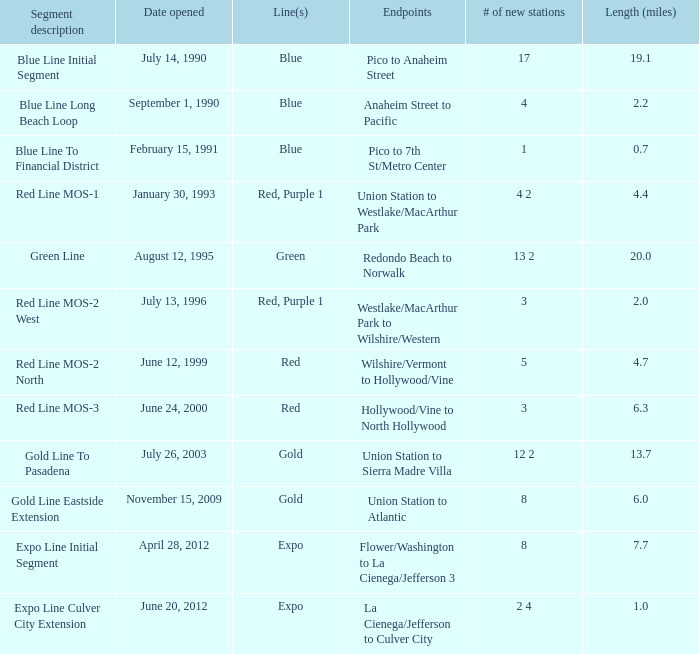What is the number of lines in the segment description of the red line mos-2 west? Red, Purple 1. 